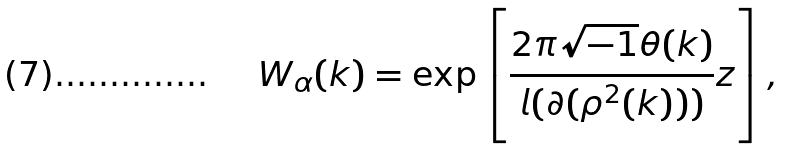<formula> <loc_0><loc_0><loc_500><loc_500>W _ { \alpha } ( k ) = \exp \left [ \frac { 2 \pi \sqrt { - 1 } \theta ( k ) } { l ( \partial ( \rho ^ { 2 } ( k ) ) ) } z \right ] ,</formula> 